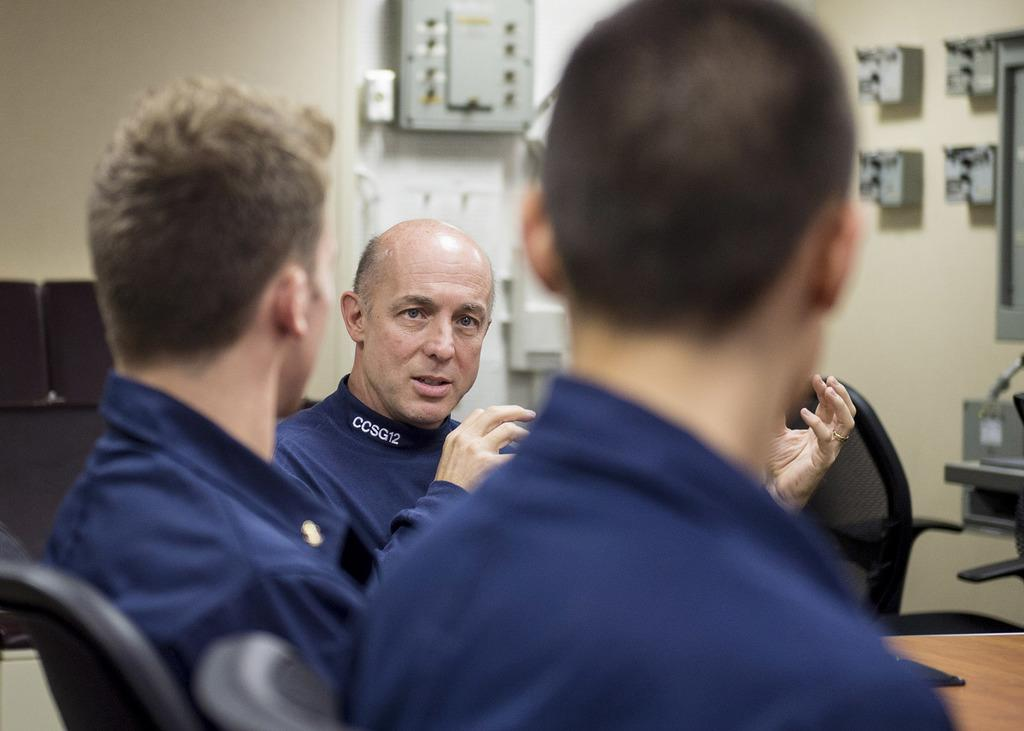What is the man in the image doing? The man in the image is speaking. What color dresses are the three men wearing? The three men are wearing blue color dresses. Can you describe any objects on the wall in the image? Yes, there is a plastic board on the wall in the image. What type of steel is used to make the skin of the men in the image? There is no mention of steel or skin in the image; the men are wearing blue color dresses. 